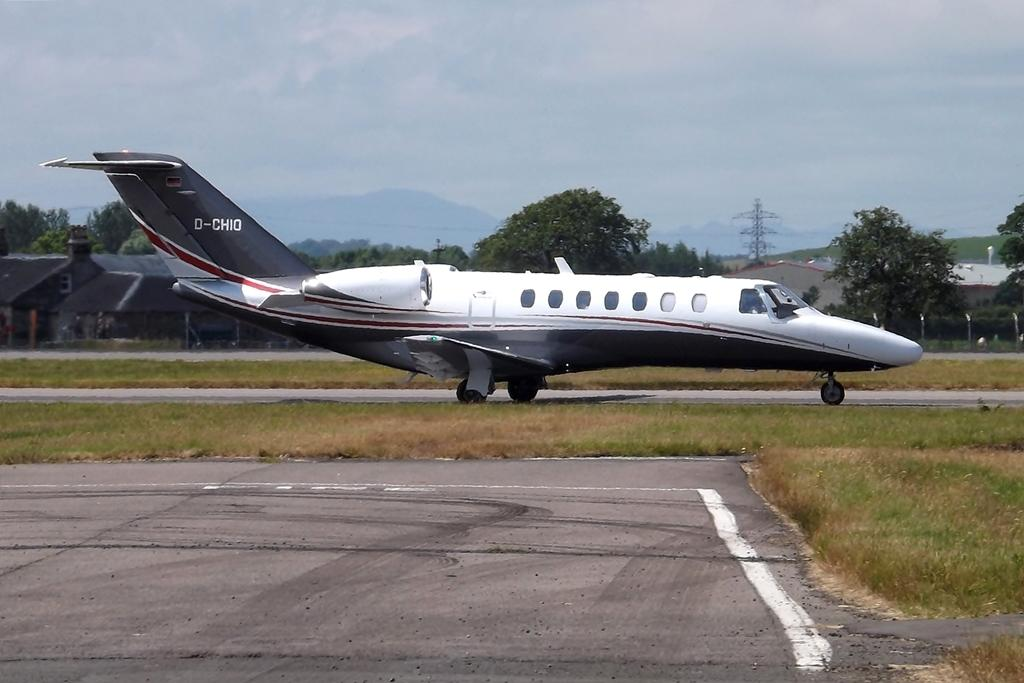<image>
Render a clear and concise summary of the photo. A white and blue plane is marked D-CH10 on the tail. 